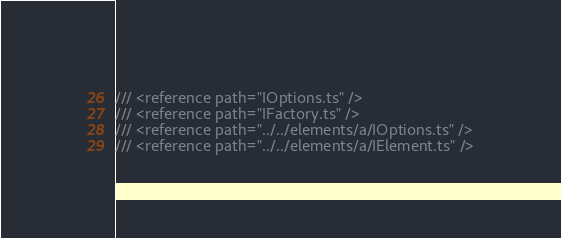<code> <loc_0><loc_0><loc_500><loc_500><_TypeScript_>/// <reference path="IOptions.ts" />
/// <reference path="IFactory.ts" />
/// <reference path="../../elements/a/IOptions.ts" />
/// <reference path="../../elements/a/IElement.ts" /></code> 